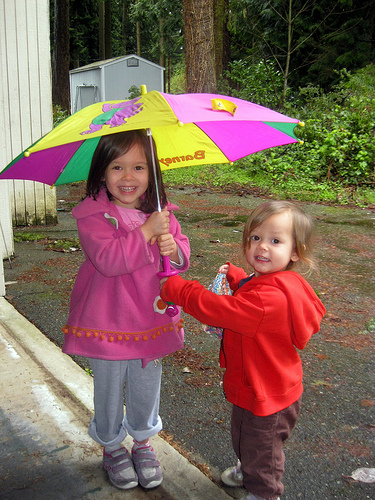Can you tell what the weather is like? From the image, it seems overcast and likely to be rainy, as the children are holding an umbrella. 